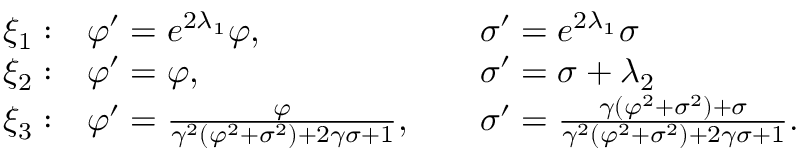<formula> <loc_0><loc_0><loc_500><loc_500>\begin{array} { l l l } { { { \xi } _ { 1 } \colon } } & { { \varphi ^ { \prime } = e ^ { 2 { \lambda } _ { 1 } } \varphi , \, } } & { { { \sigma } ^ { \prime } = e ^ { 2 { \lambda } _ { 1 } } \sigma } } \\ { { { \xi } _ { 2 } \colon } } & { { \varphi ^ { \prime } = \varphi , \, } } & { { { \sigma } ^ { \prime } = \sigma + { \lambda } _ { 2 } } } \\ { { { \xi } _ { 3 } \colon } } & { { \varphi ^ { \prime } = \frac { \varphi } { \gamma ^ { 2 } ( \varphi ^ { 2 } + \sigma ^ { 2 } ) + 2 \gamma \sigma + 1 } , \, } } & { { \sigma ^ { \prime } = \frac { \gamma ( \varphi ^ { 2 } + \sigma ^ { 2 } ) + \sigma } { \gamma ^ { 2 } ( \varphi ^ { 2 } + \sigma ^ { 2 } ) + 2 \gamma \sigma + 1 } . } } \end{array}</formula> 